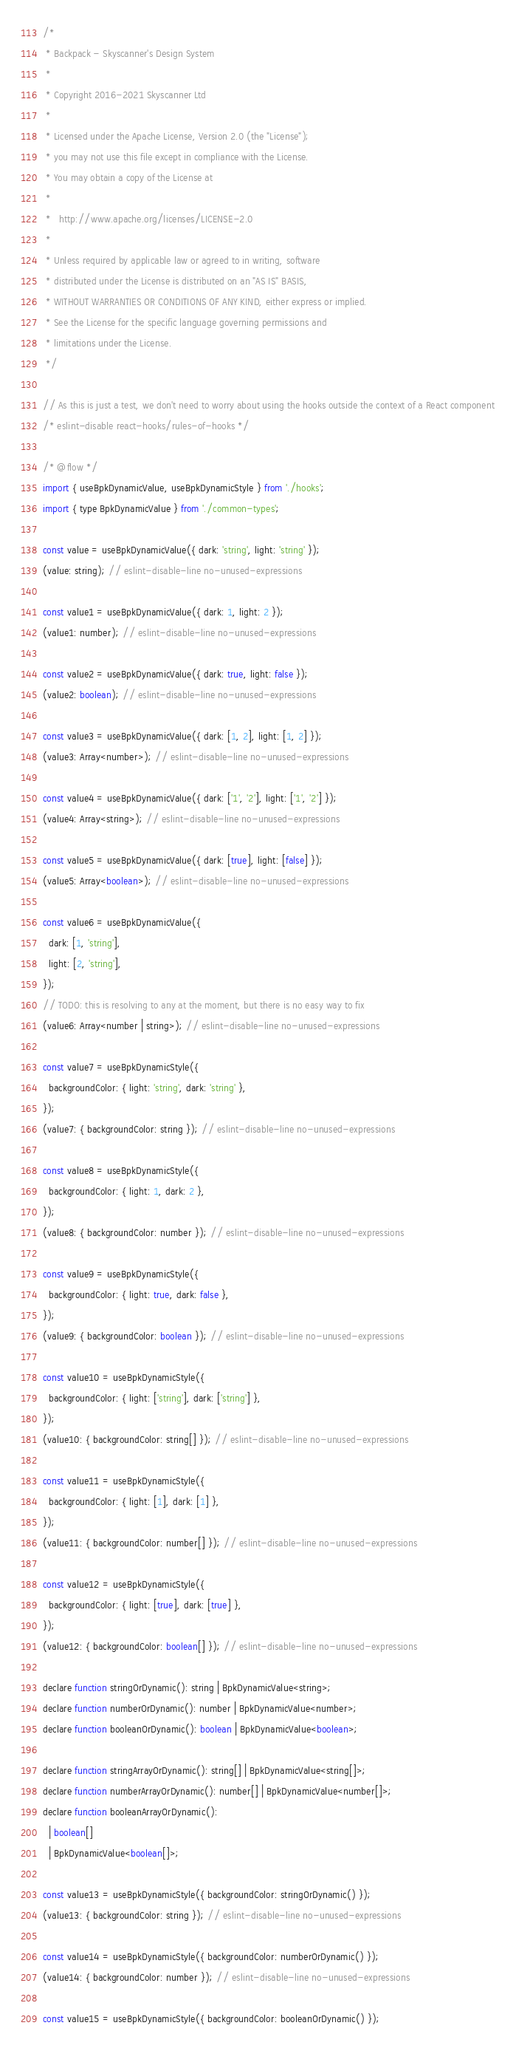Convert code to text. <code><loc_0><loc_0><loc_500><loc_500><_JavaScript_>/*
 * Backpack - Skyscanner's Design System
 *
 * Copyright 2016-2021 Skyscanner Ltd
 *
 * Licensed under the Apache License, Version 2.0 (the "License");
 * you may not use this file except in compliance with the License.
 * You may obtain a copy of the License at
 *
 *   http://www.apache.org/licenses/LICENSE-2.0
 *
 * Unless required by applicable law or agreed to in writing, software
 * distributed under the License is distributed on an "AS IS" BASIS,
 * WITHOUT WARRANTIES OR CONDITIONS OF ANY KIND, either express or implied.
 * See the License for the specific language governing permissions and
 * limitations under the License.
 */

// As this is just a test, we don't need to worry about using the hooks outside the context of a React component
/* eslint-disable react-hooks/rules-of-hooks */

/* @flow */
import { useBpkDynamicValue, useBpkDynamicStyle } from './hooks';
import { type BpkDynamicValue } from './common-types';

const value = useBpkDynamicValue({ dark: 'string', light: 'string' });
(value: string); // eslint-disable-line no-unused-expressions

const value1 = useBpkDynamicValue({ dark: 1, light: 2 });
(value1: number); // eslint-disable-line no-unused-expressions

const value2 = useBpkDynamicValue({ dark: true, light: false });
(value2: boolean); // eslint-disable-line no-unused-expressions

const value3 = useBpkDynamicValue({ dark: [1, 2], light: [1, 2] });
(value3: Array<number>); // eslint-disable-line no-unused-expressions

const value4 = useBpkDynamicValue({ dark: ['1', '2'], light: ['1', '2'] });
(value4: Array<string>); // eslint-disable-line no-unused-expressions

const value5 = useBpkDynamicValue({ dark: [true], light: [false] });
(value5: Array<boolean>); // eslint-disable-line no-unused-expressions

const value6 = useBpkDynamicValue({
  dark: [1, 'string'],
  light: [2, 'string'],
});
// TODO: this is resolving to any at the moment, but there is no easy way to fix
(value6: Array<number | string>); // eslint-disable-line no-unused-expressions

const value7 = useBpkDynamicStyle({
  backgroundColor: { light: 'string', dark: 'string' },
});
(value7: { backgroundColor: string }); // eslint-disable-line no-unused-expressions

const value8 = useBpkDynamicStyle({
  backgroundColor: { light: 1, dark: 2 },
});
(value8: { backgroundColor: number }); // eslint-disable-line no-unused-expressions

const value9 = useBpkDynamicStyle({
  backgroundColor: { light: true, dark: false },
});
(value9: { backgroundColor: boolean }); // eslint-disable-line no-unused-expressions

const value10 = useBpkDynamicStyle({
  backgroundColor: { light: ['string'], dark: ['string'] },
});
(value10: { backgroundColor: string[] }); // eslint-disable-line no-unused-expressions

const value11 = useBpkDynamicStyle({
  backgroundColor: { light: [1], dark: [1] },
});
(value11: { backgroundColor: number[] }); // eslint-disable-line no-unused-expressions

const value12 = useBpkDynamicStyle({
  backgroundColor: { light: [true], dark: [true] },
});
(value12: { backgroundColor: boolean[] }); // eslint-disable-line no-unused-expressions

declare function stringOrDynamic(): string | BpkDynamicValue<string>;
declare function numberOrDynamic(): number | BpkDynamicValue<number>;
declare function booleanOrDynamic(): boolean | BpkDynamicValue<boolean>;

declare function stringArrayOrDynamic(): string[] | BpkDynamicValue<string[]>;
declare function numberArrayOrDynamic(): number[] | BpkDynamicValue<number[]>;
declare function booleanArrayOrDynamic():
  | boolean[]
  | BpkDynamicValue<boolean[]>;

const value13 = useBpkDynamicStyle({ backgroundColor: stringOrDynamic() });
(value13: { backgroundColor: string }); // eslint-disable-line no-unused-expressions

const value14 = useBpkDynamicStyle({ backgroundColor: numberOrDynamic() });
(value14: { backgroundColor: number }); // eslint-disable-line no-unused-expressions

const value15 = useBpkDynamicStyle({ backgroundColor: booleanOrDynamic() });</code> 